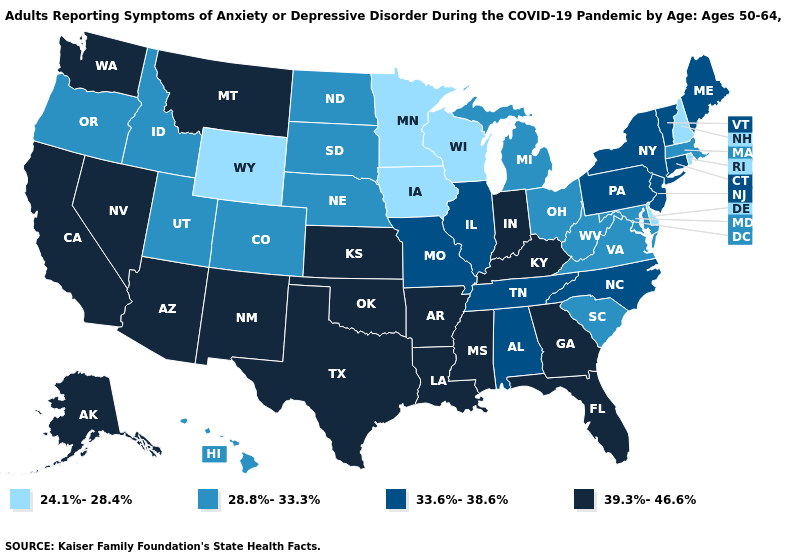What is the value of Michigan?
Write a very short answer. 28.8%-33.3%. What is the value of Massachusetts?
Short answer required. 28.8%-33.3%. What is the highest value in the USA?
Keep it brief. 39.3%-46.6%. Does New Hampshire have the lowest value in the Northeast?
Answer briefly. Yes. Name the states that have a value in the range 24.1%-28.4%?
Concise answer only. Delaware, Iowa, Minnesota, New Hampshire, Rhode Island, Wisconsin, Wyoming. Among the states that border South Carolina , does Georgia have the lowest value?
Short answer required. No. What is the lowest value in states that border Arkansas?
Give a very brief answer. 33.6%-38.6%. What is the lowest value in the USA?
Short answer required. 24.1%-28.4%. What is the value of Georgia?
Answer briefly. 39.3%-46.6%. Which states have the lowest value in the USA?
Quick response, please. Delaware, Iowa, Minnesota, New Hampshire, Rhode Island, Wisconsin, Wyoming. Name the states that have a value in the range 24.1%-28.4%?
Give a very brief answer. Delaware, Iowa, Minnesota, New Hampshire, Rhode Island, Wisconsin, Wyoming. Name the states that have a value in the range 28.8%-33.3%?
Give a very brief answer. Colorado, Hawaii, Idaho, Maryland, Massachusetts, Michigan, Nebraska, North Dakota, Ohio, Oregon, South Carolina, South Dakota, Utah, Virginia, West Virginia. What is the value of New Mexico?
Write a very short answer. 39.3%-46.6%. Among the states that border Wisconsin , which have the highest value?
Be succinct. Illinois. What is the lowest value in the USA?
Keep it brief. 24.1%-28.4%. 